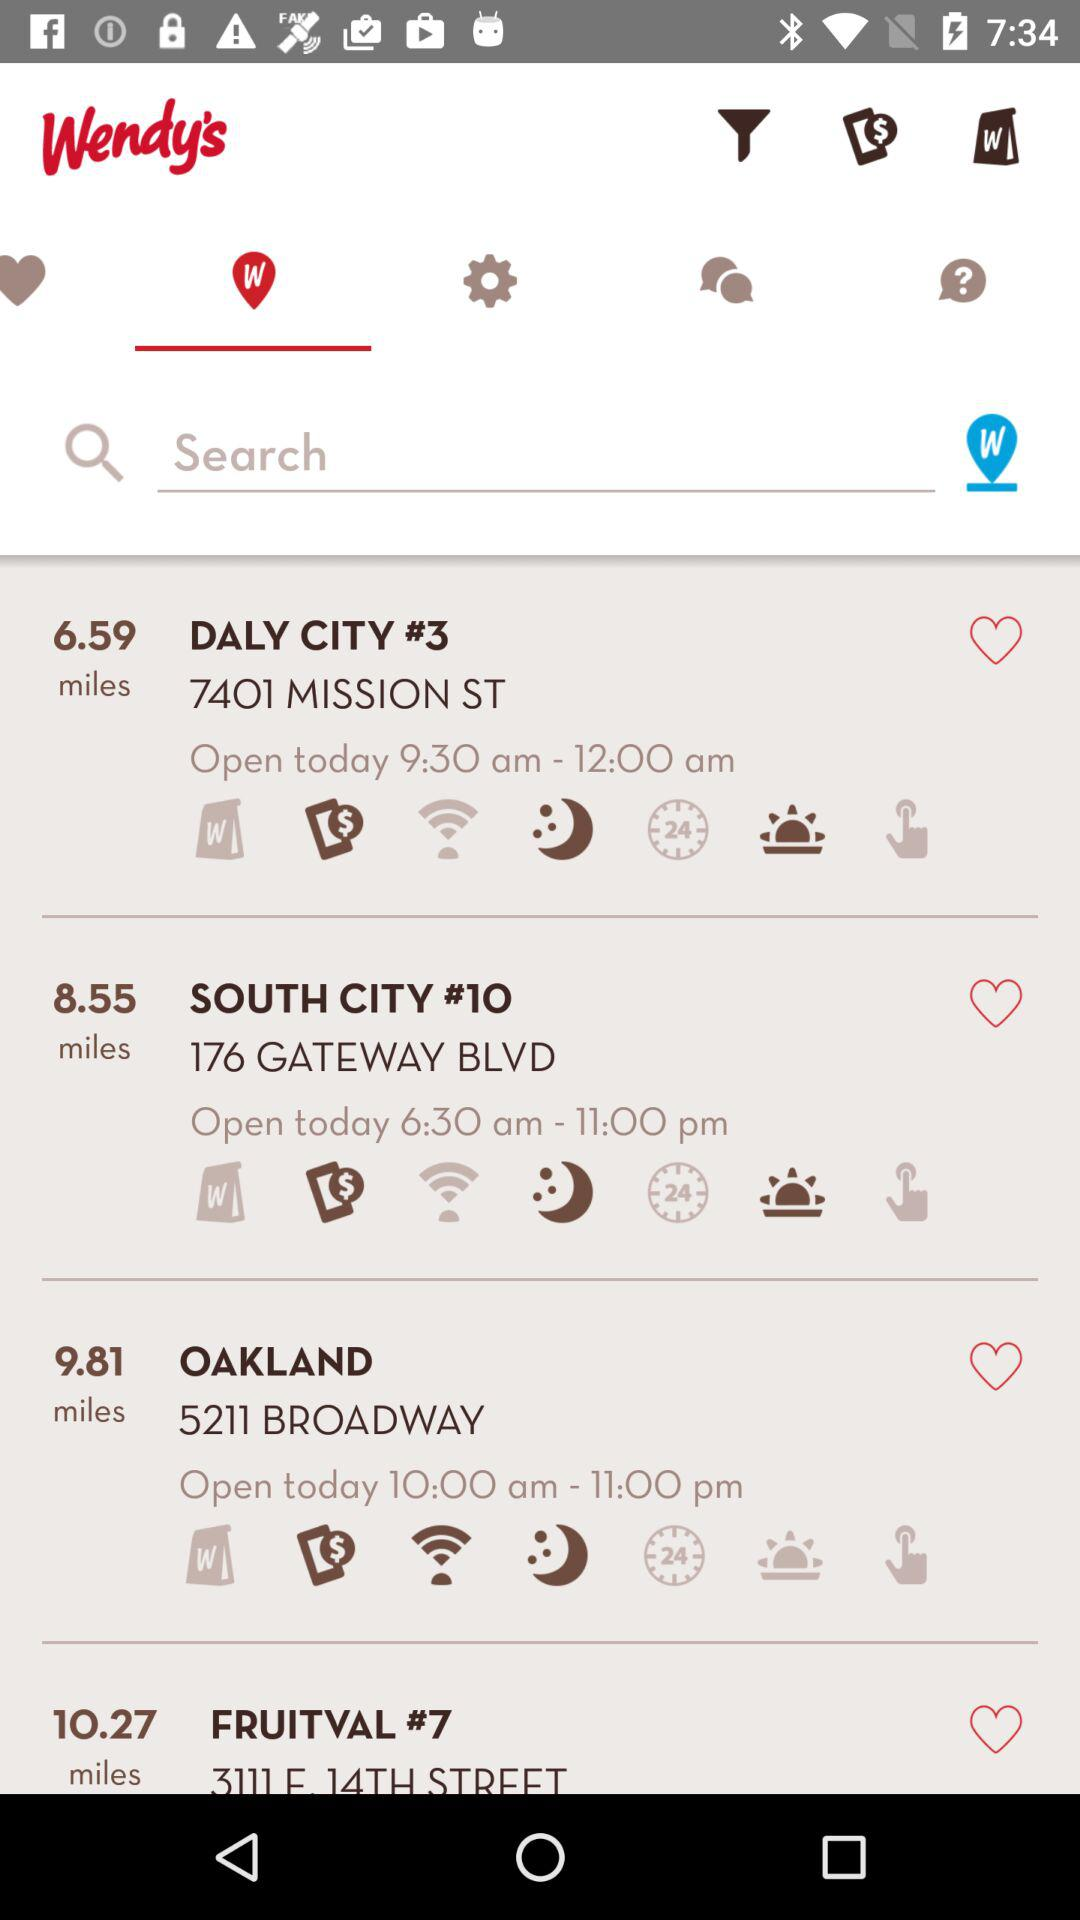What is the location of Daly City #3? The location of Daly City #3 is 7401 Mission St. 